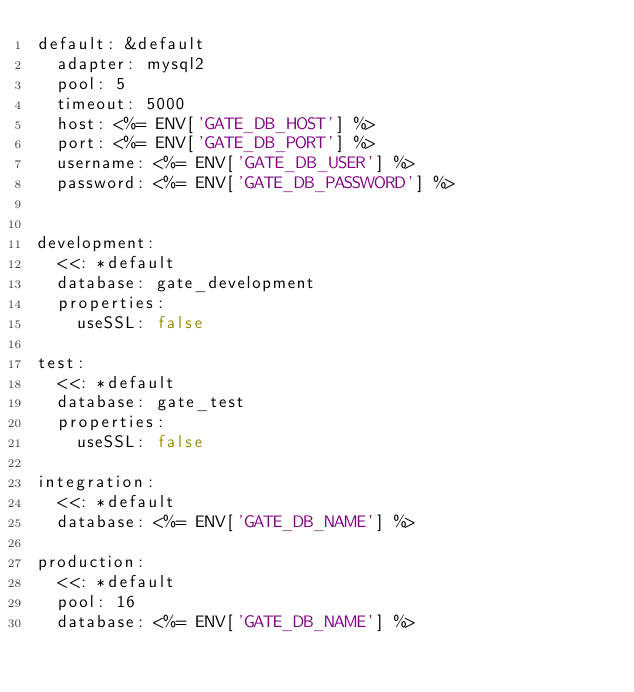Convert code to text. <code><loc_0><loc_0><loc_500><loc_500><_YAML_>default: &default
  adapter: mysql2
  pool: 5
  timeout: 5000
  host: <%= ENV['GATE_DB_HOST'] %>
  port: <%= ENV['GATE_DB_PORT'] %>
  username: <%= ENV['GATE_DB_USER'] %>
  password: <%= ENV['GATE_DB_PASSWORD'] %>


development:
  <<: *default
  database: gate_development
  properties:
    useSSL: false

test:
  <<: *default
  database: gate_test
  properties:
    useSSL: false

integration:
  <<: *default
  database: <%= ENV['GATE_DB_NAME'] %>

production:
  <<: *default
  pool: 16
  database: <%= ENV['GATE_DB_NAME'] %>
</code> 